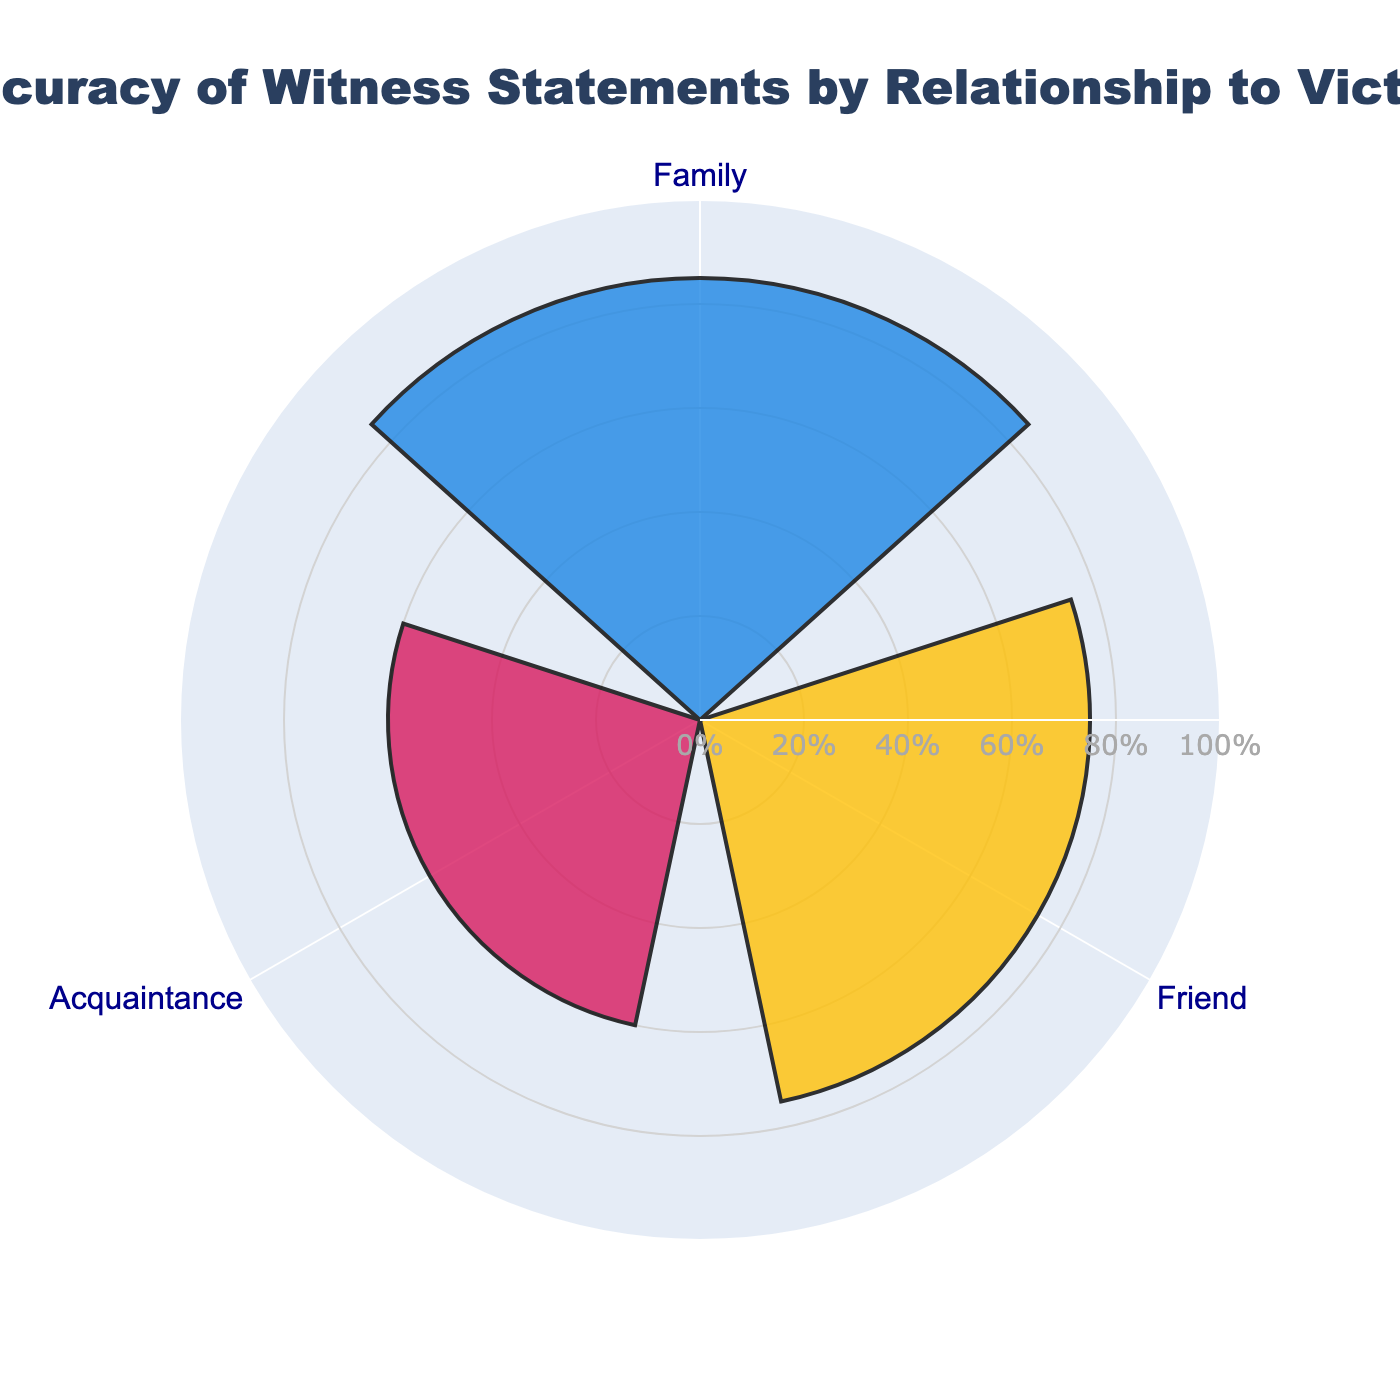What is the title of the figure? The title is shown at the top of the figure. It provides an overall description of what the figure represents: "Accuracy of Witness Statements by Relationship to Victim".
Answer: Accuracy of Witness Statements by Relationship to Victim How many relationship groups are displayed in the figure? By observing the figure, you can see the labels around the circle, indicating that there are three groups displayed.
Answer: Three Which relationship has the highest accuracy percentage? The relationship with the highest value on the radial axis (85%) corresponds to the group labeled 'Family'.
Answer: Family What is the accuracy percentage for friends' statements? The accuracy percentage can be read directly from the radial axis value that extends out from the point labeled 'Friend' which shows 75%.
Answer: 75% Is the accuracy of acquaintances' statements higher than that of strangers'? The figure shows the accuracy of acquaintance statements at 60% and that of stranger statements at 50%. Clearly, 60% is higher than 50%.
Answer: Yes What is the average accuracy percentage of the top three groups? The top three groups are Family (85%), Friend (75%), and Acquaintance (60%). The average is calculated as (85 + 75 + 60) / 3 = 220 / 3 ≈ 73.33
Answer: 73.33 What is the difference in accuracy percentages between family and acquaintance statements? Subtract the accuracy percentage of Acquaintance (60%) from that of Family (85%): 85 - 60 = 25.
Answer: 25 If a new relationship group with an accuracy percentage of 80% was added, which two original groups would it fall between? An accuracy of 80% would fall between Family (85%) and Friend (75%) according to the data shown in the figure.
Answer: Family and Friend Which color represents the friends' group in the figure? The color associated with the Friend group, as shown by the marking in the figure, is yellow. Among the colors blue, yellow, and pink, the middle one represents the Friend group.
Answer: Yellow 